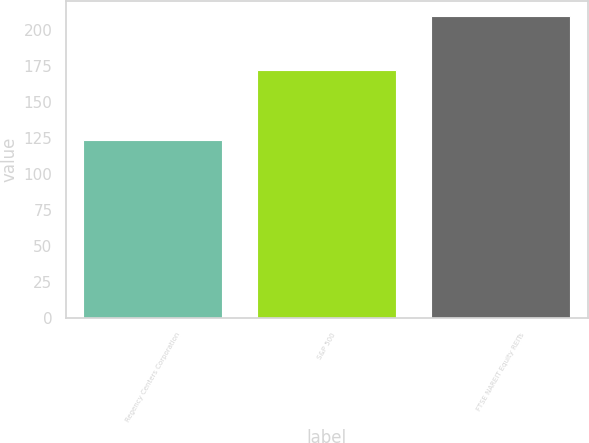Convert chart to OTSL. <chart><loc_0><loc_0><loc_500><loc_500><bar_chart><fcel>Regency Centers Corporation<fcel>S&P 500<fcel>FTSE NAREIT Equity REITs<nl><fcel>123.39<fcel>172.37<fcel>209.39<nl></chart> 